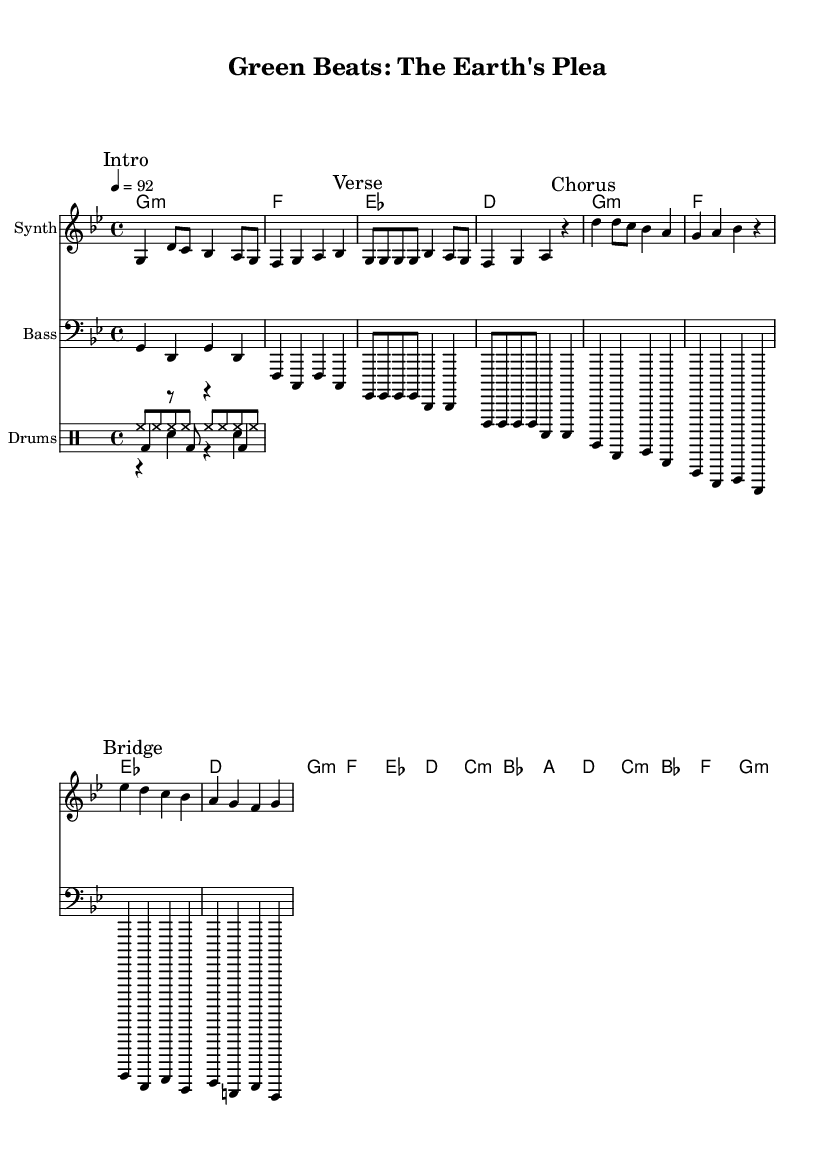What is the key signature of this music? The key signature indicated in the music is G minor, as shown by the presence of two flats (B♭ and E♭) in the key signature section.
Answer: G minor What is the time signature of this music? The time signature is 4/4, which means there are four beats in each measure and the quarter note receives one beat. This is clearly marked in the music composition.
Answer: 4/4 What is the tempo marking for this music? The tempo marking is 92 beats per minute, which is denoted in the score to indicate the speed at which the piece should be played.
Answer: 92 How many measures are in the chorus section? The chorus section consists of 4 measures, as outlined in the score with the specific melody and chord changes marked.
Answer: 4 measures What instruments are included in this arrangement? The arrangement consists of a synthesizer for the melody, a bass instrument for the bassline, and drums for rhythm, confirmed by the instruments' names specified in the score.
Answer: Synth, Bass, Drums What is the function of the "Bridge" in this music? The bridge serves as a contrasting section that provides a transition from the verse to the chorus, typically enhancing the song's dynamics and progression, indicated by the marked section in the score.
Answer: Contrasting section How does the repetition of "g" notes in the first verse contribute to this rap's overall feel? The repetition of the "g" notes emphasizes rhythm and serves to create a catchy hook, forming a foundational element for the rap's flow, as demonstrated in the melodic line.
Answer: Creates a catchy hook 